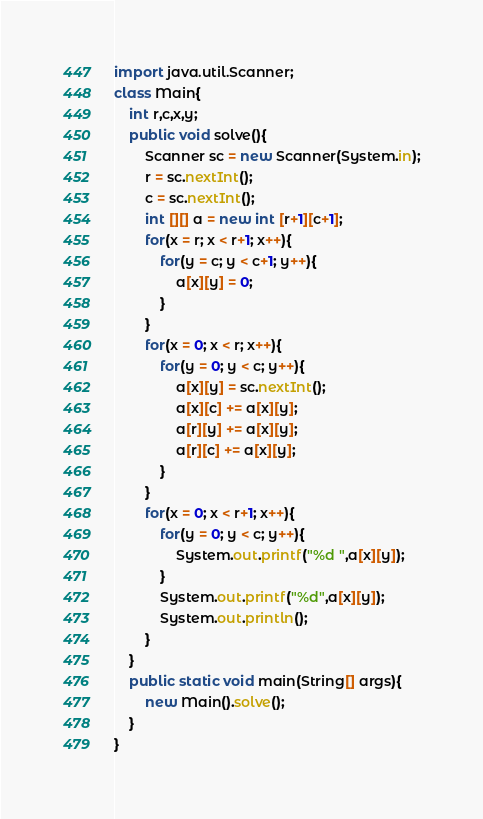Convert code to text. <code><loc_0><loc_0><loc_500><loc_500><_Java_>import java.util.Scanner;
class Main{
    int r,c,x,y;
    public void solve(){
        Scanner sc = new Scanner(System.in);
        r = sc.nextInt();
        c = sc.nextInt();
        int [][] a = new int [r+1][c+1];
        for(x = r; x < r+1; x++){
            for(y = c; y < c+1; y++){
                a[x][y] = 0;
            }
        }
        for(x = 0; x < r; x++){
            for(y = 0; y < c; y++){
                a[x][y] = sc.nextInt();
                a[x][c] += a[x][y];
                a[r][y] += a[x][y];
                a[r][c] += a[x][y];
            }
        }
        for(x = 0; x < r+1; x++){
            for(y = 0; y < c; y++){
                System.out.printf("%d ",a[x][y]);
            }
            System.out.printf("%d",a[x][y]);
            System.out.println();
        }
    }
    public static void main(String[] args){
        new Main().solve();
    }
}</code> 